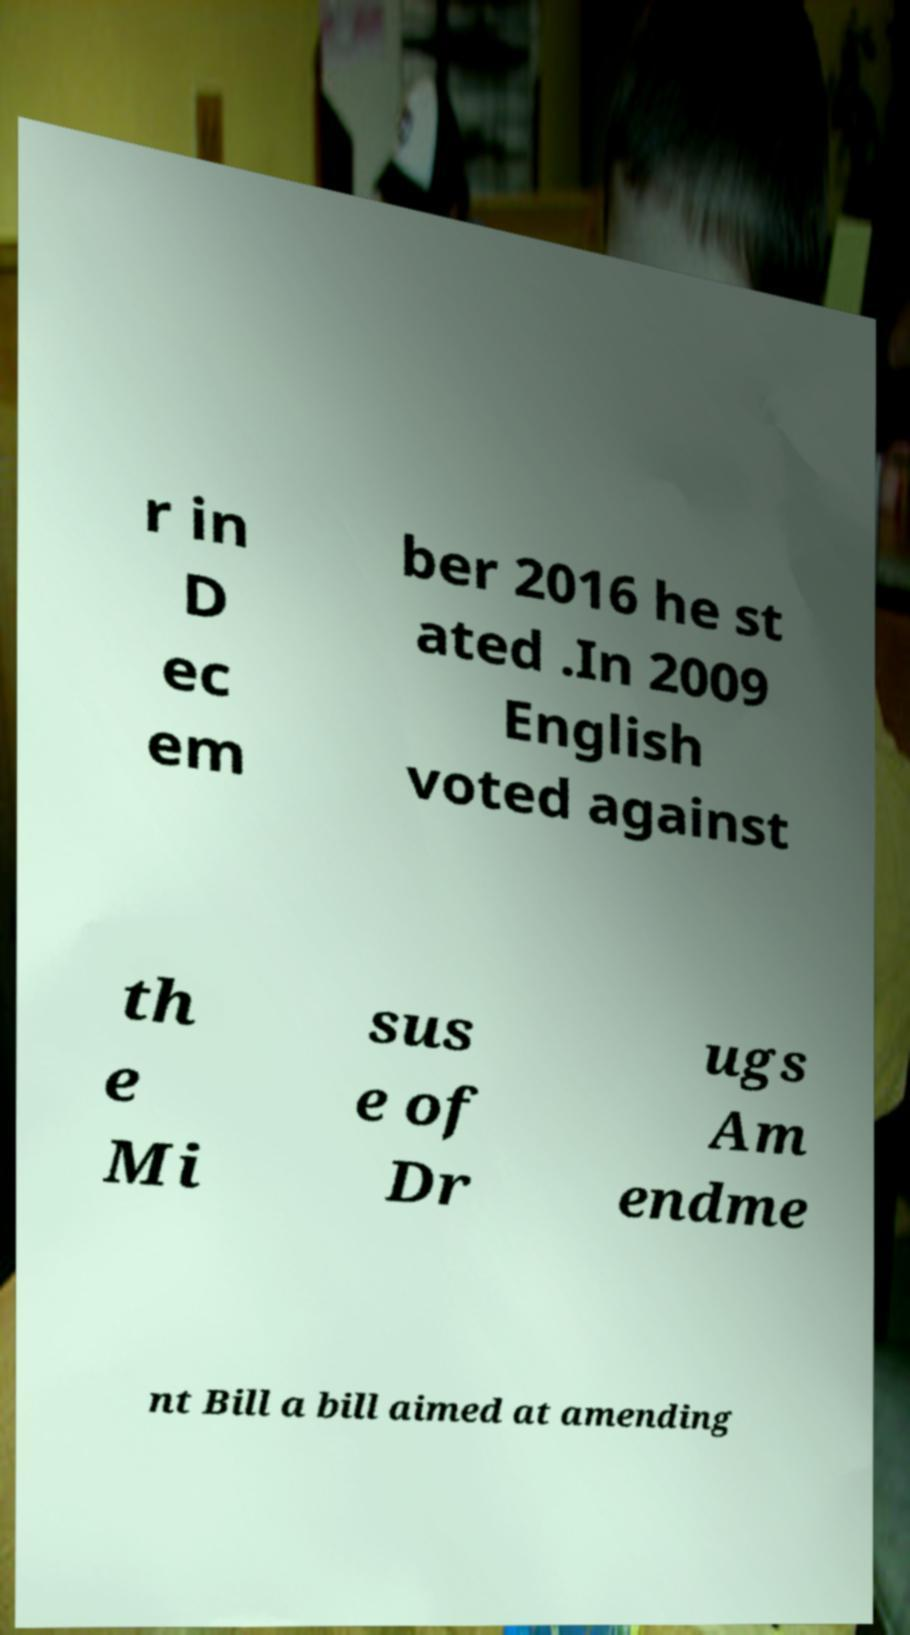What messages or text are displayed in this image? I need them in a readable, typed format. r in D ec em ber 2016 he st ated .In 2009 English voted against th e Mi sus e of Dr ugs Am endme nt Bill a bill aimed at amending 